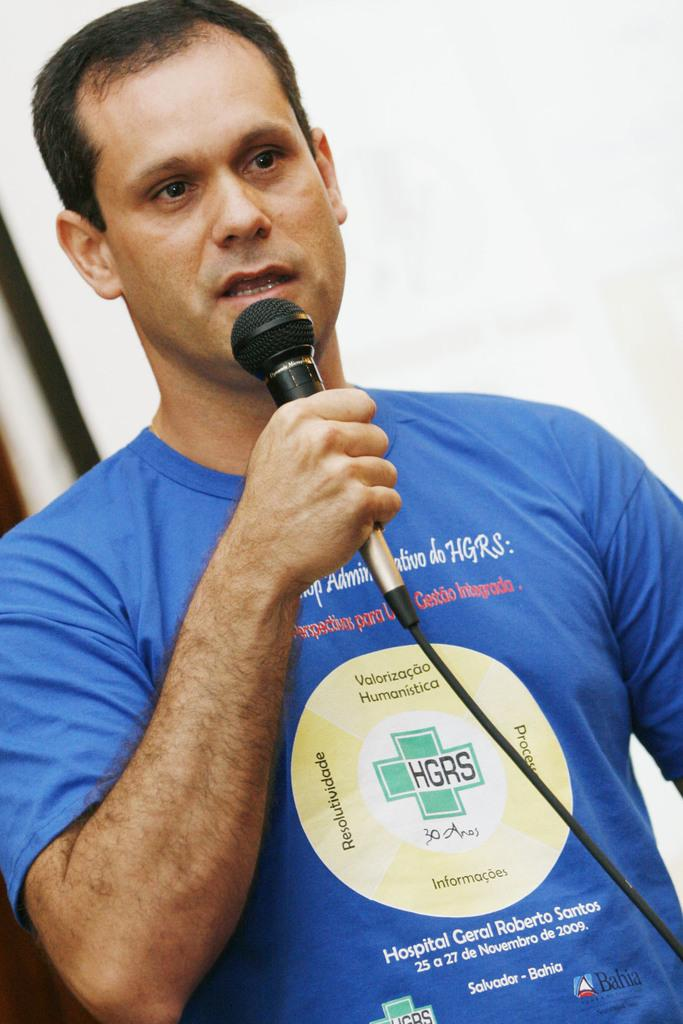What is the main subject of the image? There is a person in the image. What is the person wearing? The person is wearing a blue t-shirt. What is the person holding in the image? The person is holding a mic. Can you describe the t-shirt the person is wearing? The t-shirt has writing on it. What can be seen in the background of the image? There is a white wall in the background. What type of toys can be seen on the coast during the person's vacation in the image? There is no mention of a vacation, coast, or toys in the image. The image only features a person wearing a blue t-shirt, holding a mic, and standing in front of a white wall. 